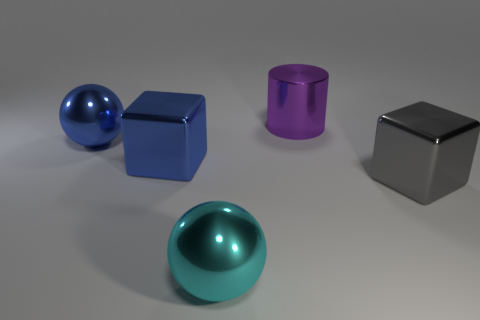Is there a big shiny ball that is in front of the cyan ball that is on the left side of the big gray object?
Ensure brevity in your answer.  No. Are the big cube left of the big purple cylinder and the big blue sphere made of the same material?
Your answer should be compact. Yes. What number of big objects are both right of the large shiny cylinder and left of the big cyan thing?
Your answer should be compact. 0. How many cylinders are the same material as the big gray thing?
Keep it short and to the point. 1. There is a cylinder that is made of the same material as the cyan ball; what is its color?
Ensure brevity in your answer.  Purple. Is the number of blue metallic balls less than the number of tiny red rubber cylinders?
Your answer should be very brief. No. What material is the big block right of the big sphere that is in front of the large metallic sphere that is left of the cyan thing?
Your answer should be compact. Metal. What material is the blue block?
Your response must be concise. Metal. There is a metal sphere that is left of the blue metal cube; is it the same color as the large shiny ball in front of the big blue ball?
Your answer should be very brief. No. Is the number of large cyan balls greater than the number of big blue things?
Give a very brief answer. No. 